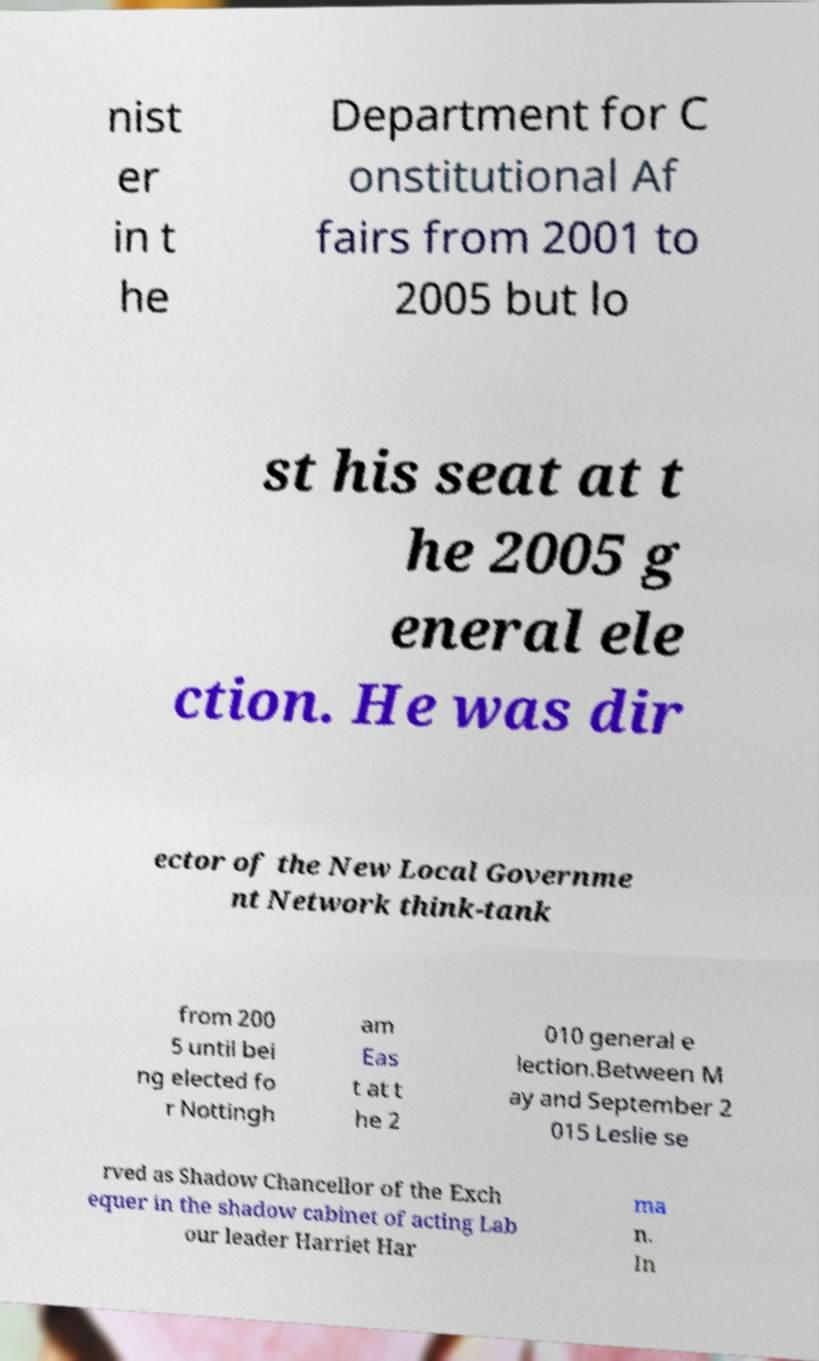For documentation purposes, I need the text within this image transcribed. Could you provide that? nist er in t he Department for C onstitutional Af fairs from 2001 to 2005 but lo st his seat at t he 2005 g eneral ele ction. He was dir ector of the New Local Governme nt Network think-tank from 200 5 until bei ng elected fo r Nottingh am Eas t at t he 2 010 general e lection.Between M ay and September 2 015 Leslie se rved as Shadow Chancellor of the Exch equer in the shadow cabinet of acting Lab our leader Harriet Har ma n. In 